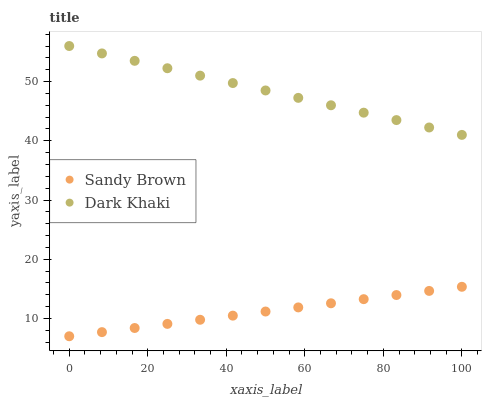Does Sandy Brown have the minimum area under the curve?
Answer yes or no. Yes. Does Dark Khaki have the maximum area under the curve?
Answer yes or no. Yes. Does Sandy Brown have the maximum area under the curve?
Answer yes or no. No. Is Sandy Brown the smoothest?
Answer yes or no. Yes. Is Dark Khaki the roughest?
Answer yes or no. Yes. Is Sandy Brown the roughest?
Answer yes or no. No. Does Sandy Brown have the lowest value?
Answer yes or no. Yes. Does Dark Khaki have the highest value?
Answer yes or no. Yes. Does Sandy Brown have the highest value?
Answer yes or no. No. Is Sandy Brown less than Dark Khaki?
Answer yes or no. Yes. Is Dark Khaki greater than Sandy Brown?
Answer yes or no. Yes. Does Sandy Brown intersect Dark Khaki?
Answer yes or no. No. 